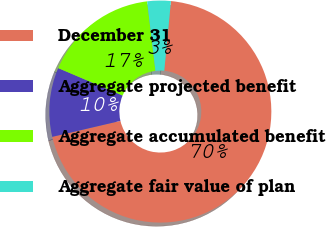<chart> <loc_0><loc_0><loc_500><loc_500><pie_chart><fcel>December 31<fcel>Aggregate projected benefit<fcel>Aggregate accumulated benefit<fcel>Aggregate fair value of plan<nl><fcel>69.82%<fcel>10.06%<fcel>16.7%<fcel>3.42%<nl></chart> 